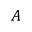<formula> <loc_0><loc_0><loc_500><loc_500>A</formula> 